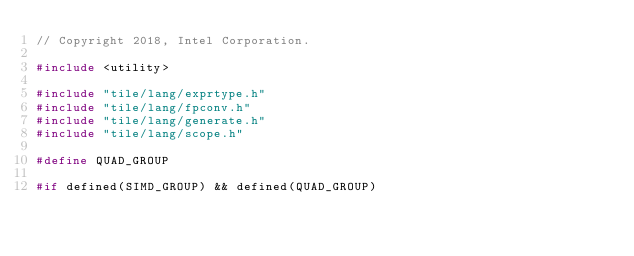Convert code to text. <code><loc_0><loc_0><loc_500><loc_500><_C++_>// Copyright 2018, Intel Corporation.

#include <utility>

#include "tile/lang/exprtype.h"
#include "tile/lang/fpconv.h"
#include "tile/lang/generate.h"
#include "tile/lang/scope.h"

#define QUAD_GROUP

#if defined(SIMD_GROUP) && defined(QUAD_GROUP)</code> 